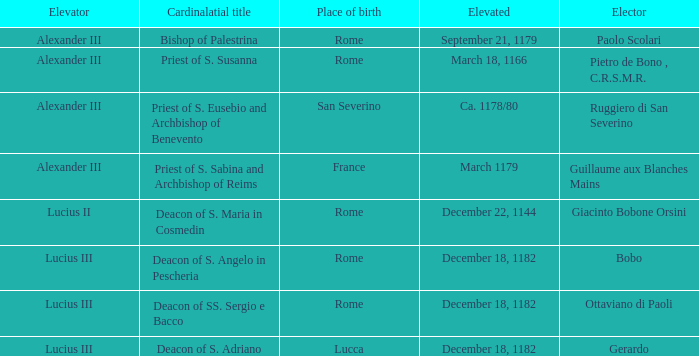What Elector was Elevated on December 18, 1182? Bobo, Ottaviano di Paoli, Gerardo. Parse the table in full. {'header': ['Elevator', 'Cardinalatial title', 'Place of birth', 'Elevated', 'Elector'], 'rows': [['Alexander III', 'Bishop of Palestrina', 'Rome', 'September 21, 1179', 'Paolo Scolari'], ['Alexander III', 'Priest of S. Susanna', 'Rome', 'March 18, 1166', 'Pietro de Bono , C.R.S.M.R.'], ['Alexander III', 'Priest of S. Eusebio and Archbishop of Benevento', 'San Severino', 'Ca. 1178/80', 'Ruggiero di San Severino'], ['Alexander III', 'Priest of S. Sabina and Archbishop of Reims', 'France', 'March 1179', 'Guillaume aux Blanches Mains'], ['Lucius II', 'Deacon of S. Maria in Cosmedin', 'Rome', 'December 22, 1144', 'Giacinto Bobone Orsini'], ['Lucius III', 'Deacon of S. Angelo in Pescheria', 'Rome', 'December 18, 1182', 'Bobo'], ['Lucius III', 'Deacon of SS. Sergio e Bacco', 'Rome', 'December 18, 1182', 'Ottaviano di Paoli'], ['Lucius III', 'Deacon of S. Adriano', 'Lucca', 'December 18, 1182', 'Gerardo']]} 